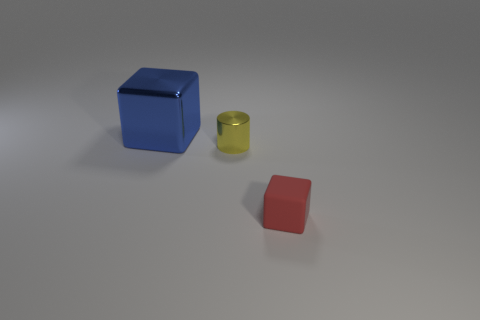Add 2 metal blocks. How many objects exist? 5 Subtract all cubes. How many objects are left? 1 Subtract 1 blue cubes. How many objects are left? 2 Subtract all tiny red objects. Subtract all red things. How many objects are left? 1 Add 3 large blue things. How many large blue things are left? 4 Add 1 tiny brown blocks. How many tiny brown blocks exist? 1 